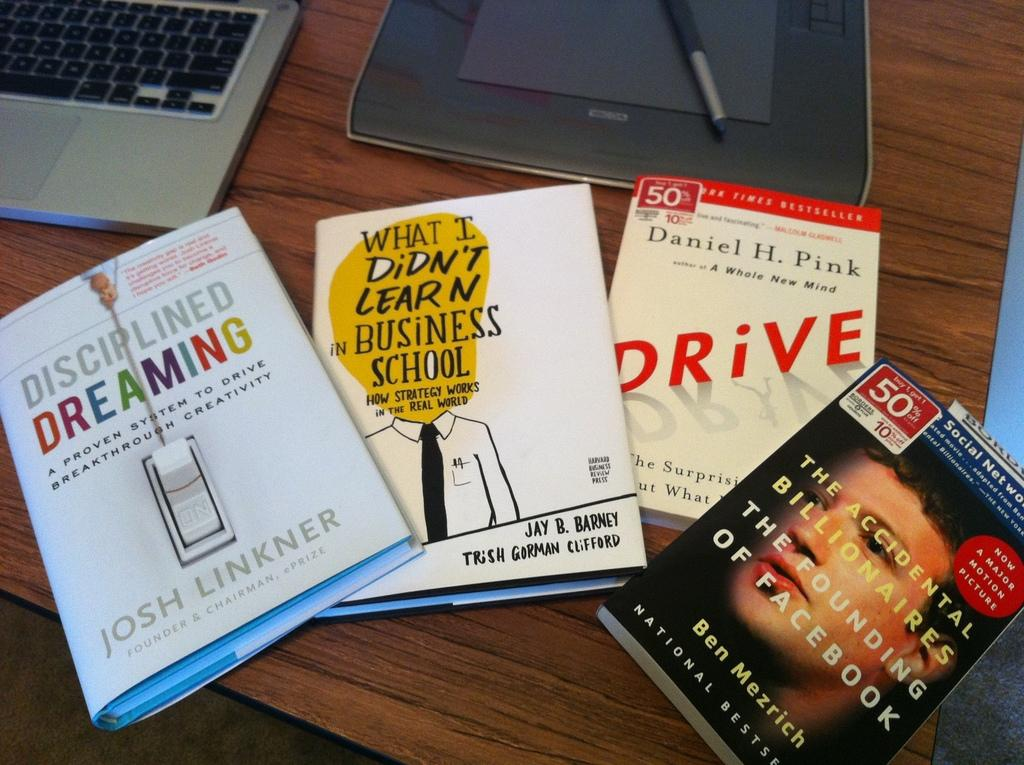<image>
Share a concise interpretation of the image provided. A book titles Disciplined Dreaming is next to other books. 